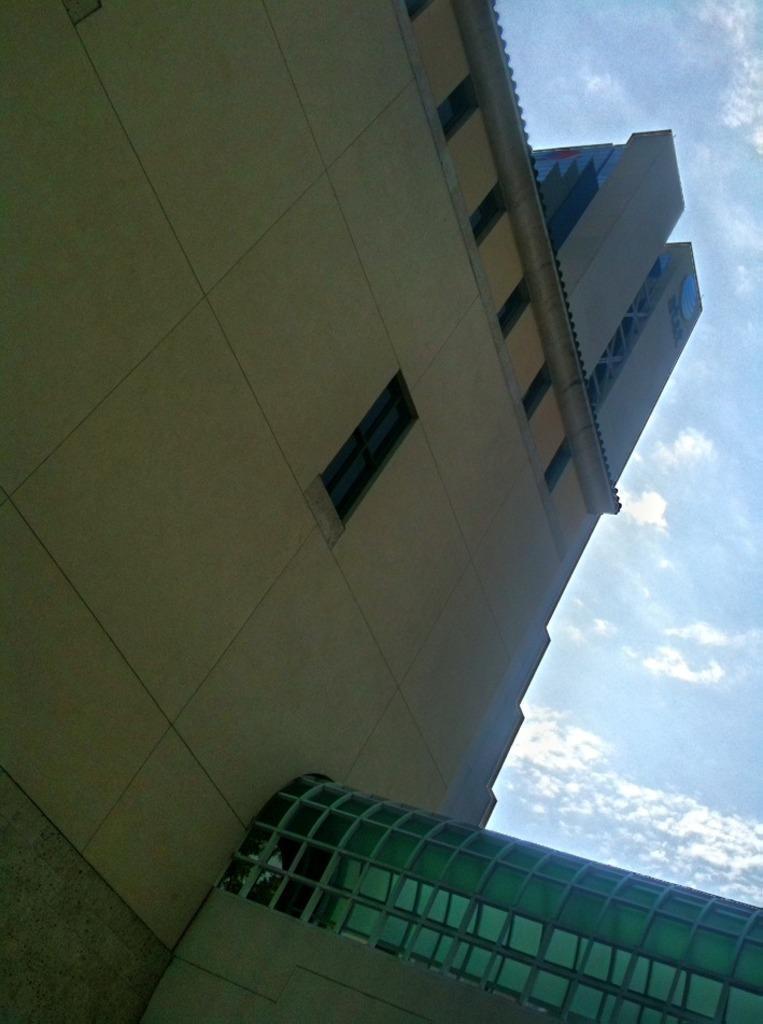Describe this image in one or two sentences. In the image there is a building with windows on the top and above its sky with clouds. 